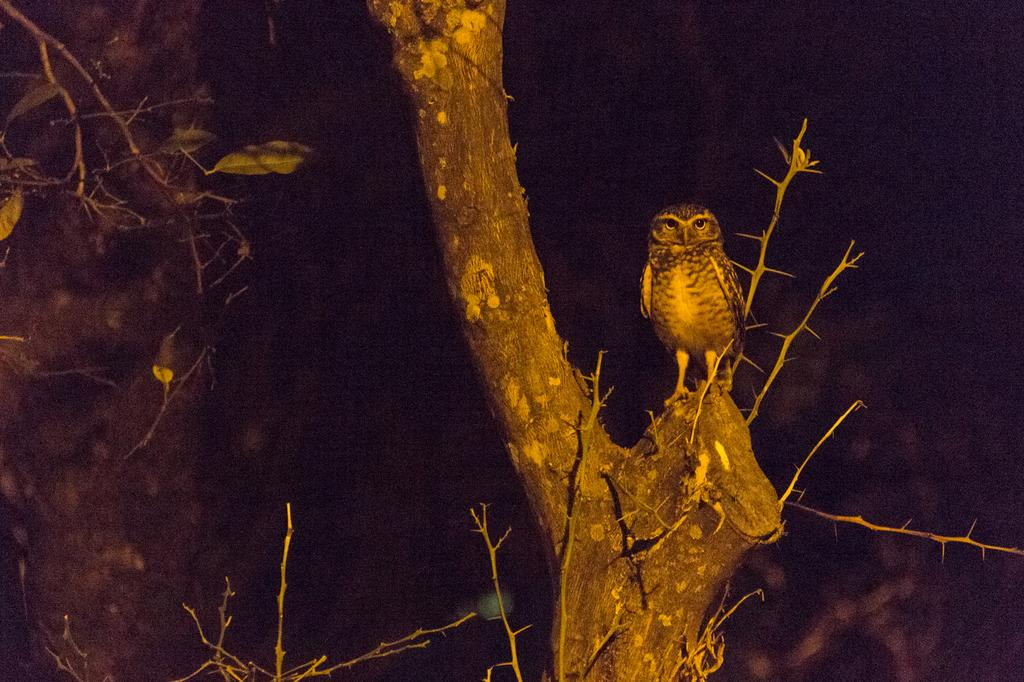What animal is present in the image? There is an owl in the image. Where is the owl located? The owl is standing on the edge of a branch of a tree. What type of vegetation is visible in the image? There are green color leaves of a tree in the image. What can be observed about the background of the image? The background of the image is dark in color. How does the owl push the tree in the image? The owl does not push the tree in the image; it is standing on the edge of a branch. 